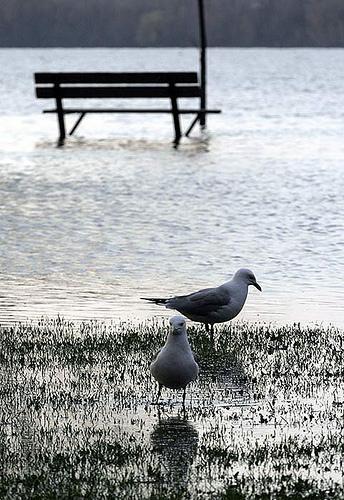How many birds can you see?
Give a very brief answer. 2. 